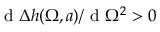<formula> <loc_0><loc_0><loc_500><loc_500>d \Delta { h } ( \Omega , a ) / d \Omega ^ { 2 } > 0</formula> 